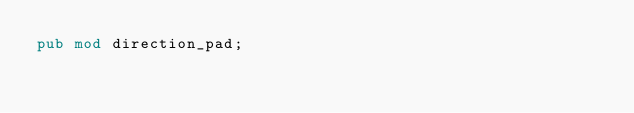<code> <loc_0><loc_0><loc_500><loc_500><_Rust_>pub mod direction_pad;</code> 